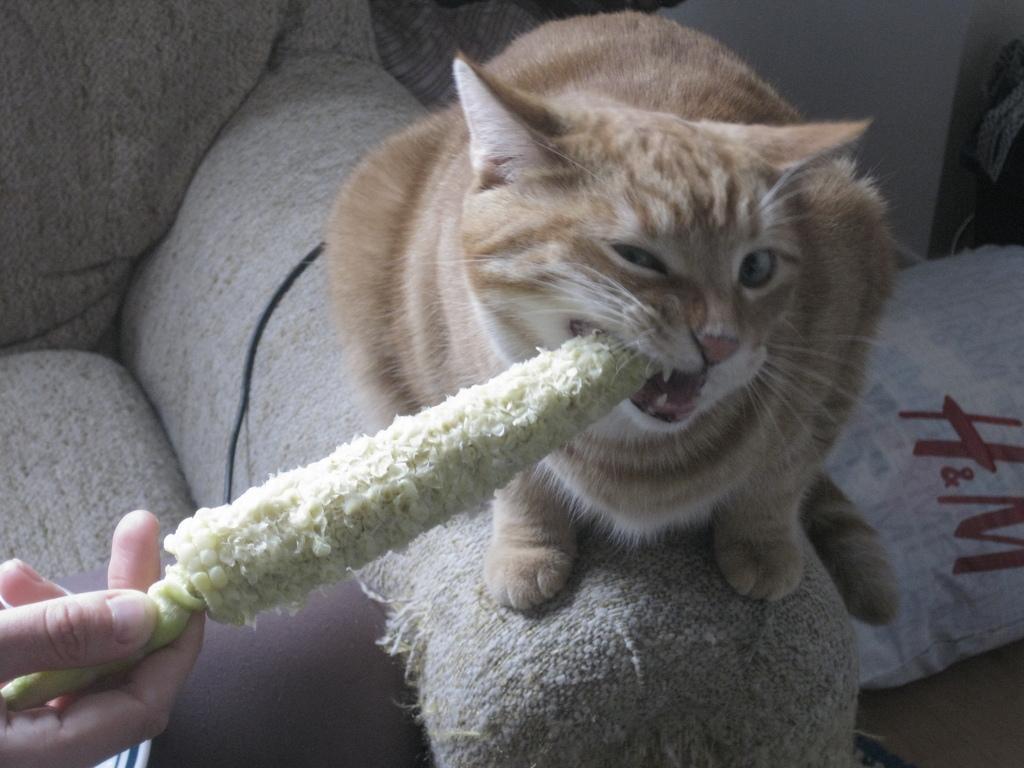Could you give a brief overview of what you see in this image? In this picture we can see a cat is sitting on a couch and a person is holding a bare corn cob and we can see only person hand. On the couch there is a cable and other things. 